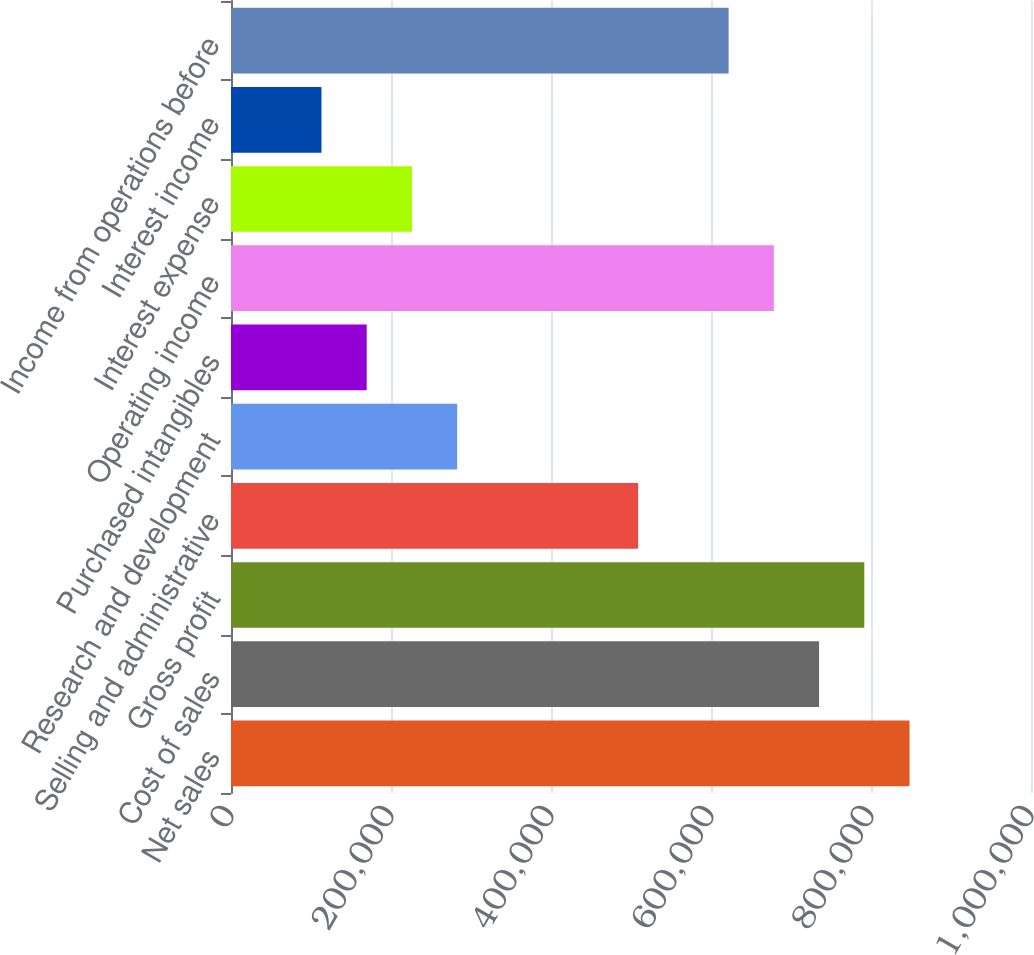Convert chart. <chart><loc_0><loc_0><loc_500><loc_500><bar_chart><fcel>Net sales<fcel>Cost of sales<fcel>Gross profit<fcel>Selling and administrative<fcel>Research and development<fcel>Purchased intangibles<fcel>Operating income<fcel>Interest expense<fcel>Interest income<fcel>Income from operations before<nl><fcel>848171<fcel>735082<fcel>791627<fcel>508903<fcel>282725<fcel>169636<fcel>678537<fcel>226180<fcel>113091<fcel>621993<nl></chart> 